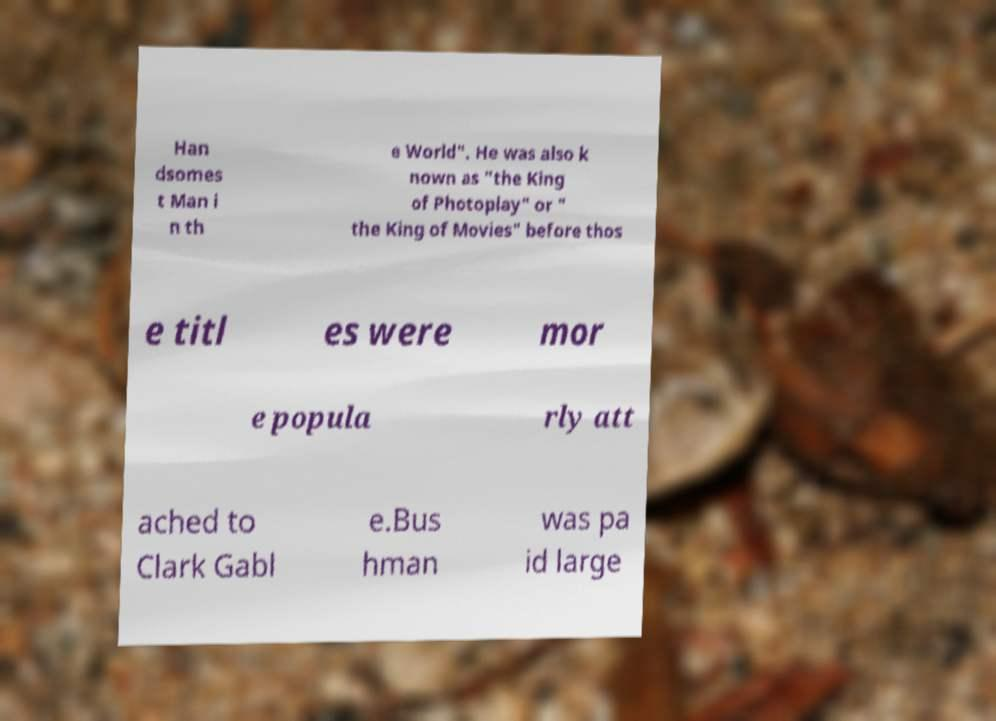Could you extract and type out the text from this image? Han dsomes t Man i n th e World". He was also k nown as "the King of Photoplay" or " the King of Movies" before thos e titl es were mor e popula rly att ached to Clark Gabl e.Bus hman was pa id large 